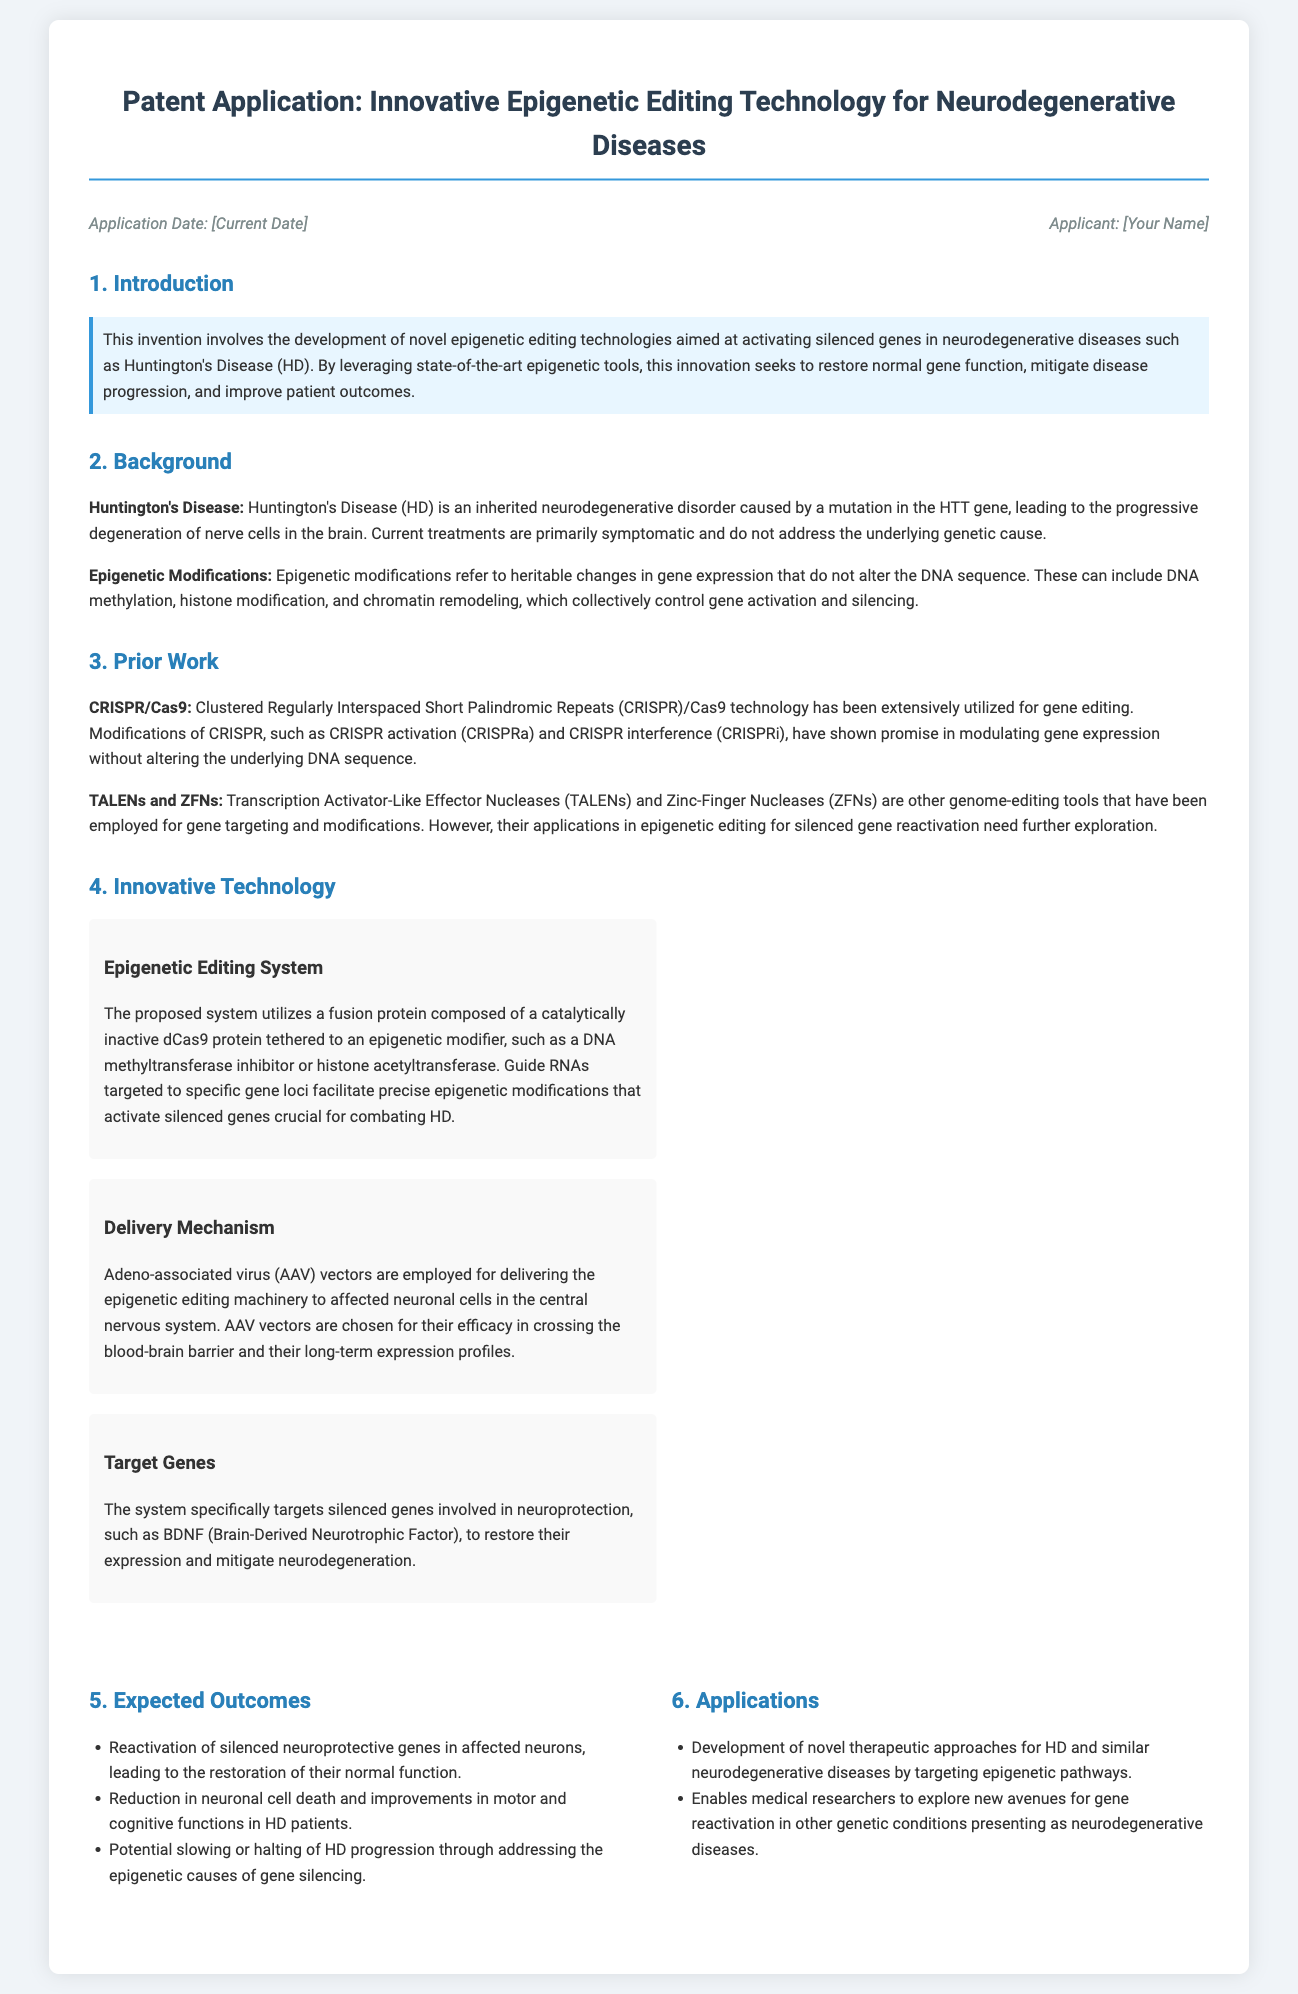What is the title of the patent application? The title is provided in the document header and outlines the focus of the application.
Answer: Innovative Epigenetic Editing Technology for Neurodegenerative Diseases What disease is primarily targeted by this invention? The background section discusses the disease that the technology aims to address specifically.
Answer: Huntington's Disease What are the main components of the proposed epigenetic editing system? The section on Innovative Technology describes the fusion protein and its relation to epigenetic modifiers.
Answer: Catalytically inactive dCas9 protein and epigenetic modifier What delivery mechanism is proposed in the document? The Innovative Technology section specifies how the epigenetic editing machinery is delivered to cells.
Answer: Adeno-associated virus vectors Which neuroprotective gene is mentioned as a target for reactivation? The section detailing Target Genes indicates which specific gene is aimed to be reactivated.
Answer: BDNF (Brain-Derived Neurotrophic Factor) What is one expected outcome of the epigenetic editing technology? The Expected Outcomes section lists results anticipated from the application of the technology.
Answer: Reactivation of silenced neuroprotective genes What is the significance of this technology in medical research? The Applications section explores broader implications of the technology beyond Huntington's Disease.
Answer: Development of novel therapeutic approaches When was the patent application submitted? The application date is listed in the application info at the top of the document.
Answer: [Current Date] 